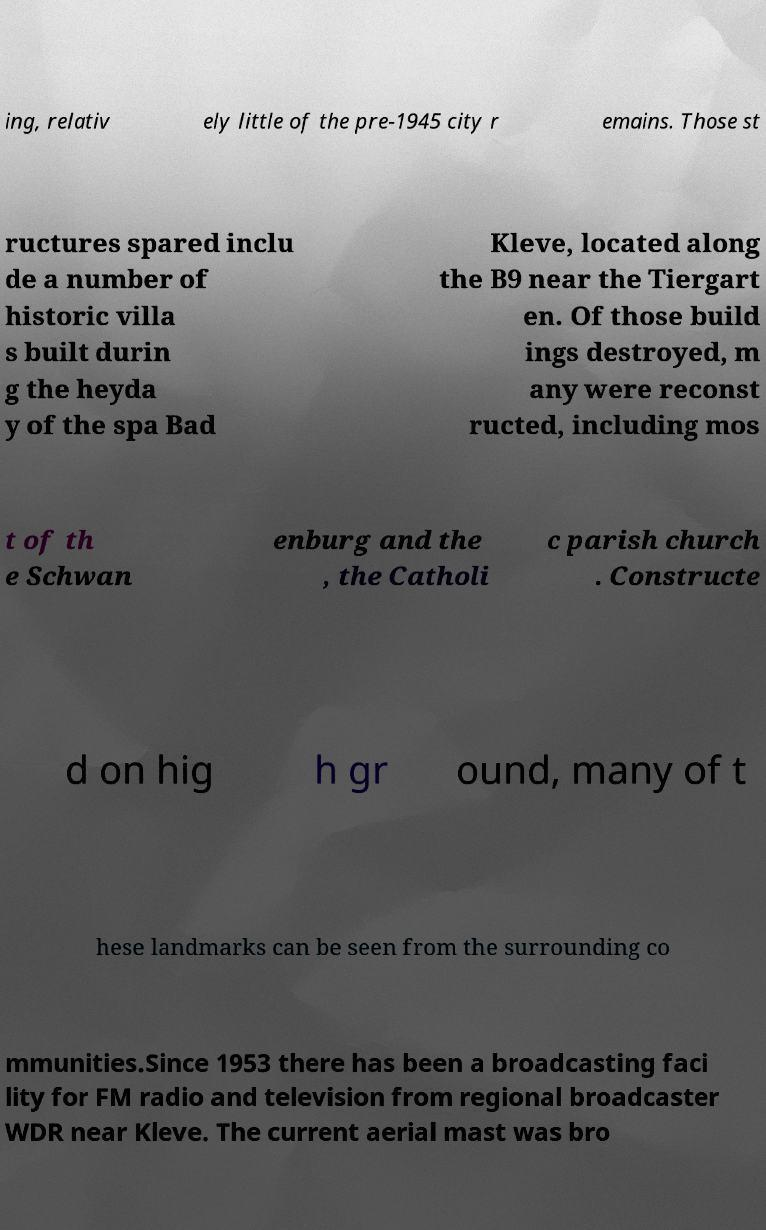Please identify and transcribe the text found in this image. ing, relativ ely little of the pre-1945 city r emains. Those st ructures spared inclu de a number of historic villa s built durin g the heyda y of the spa Bad Kleve, located along the B9 near the Tiergart en. Of those build ings destroyed, m any were reconst ructed, including mos t of th e Schwan enburg and the , the Catholi c parish church . Constructe d on hig h gr ound, many of t hese landmarks can be seen from the surrounding co mmunities.Since 1953 there has been a broadcasting faci lity for FM radio and television from regional broadcaster WDR near Kleve. The current aerial mast was bro 